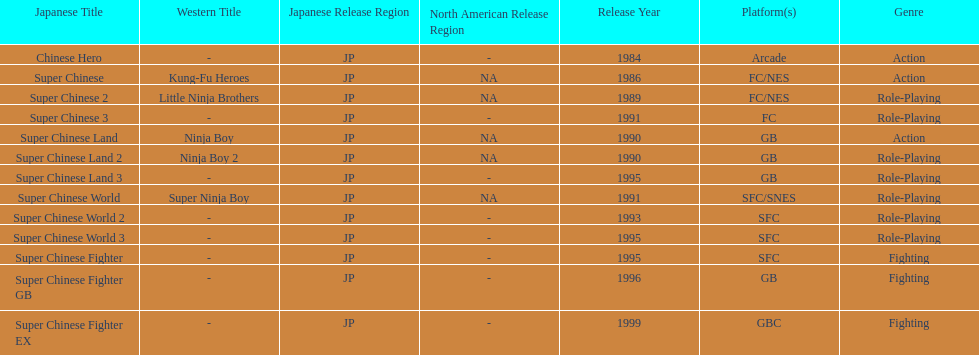When was the last super chinese game released? 1999. 